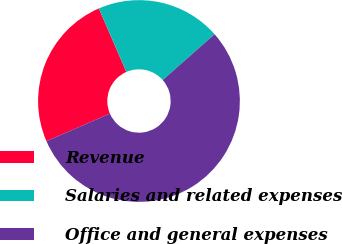Convert chart to OTSL. <chart><loc_0><loc_0><loc_500><loc_500><pie_chart><fcel>Revenue<fcel>Salaries and related expenses<fcel>Office and general expenses<nl><fcel>25.0%<fcel>20.0%<fcel>55.0%<nl></chart> 